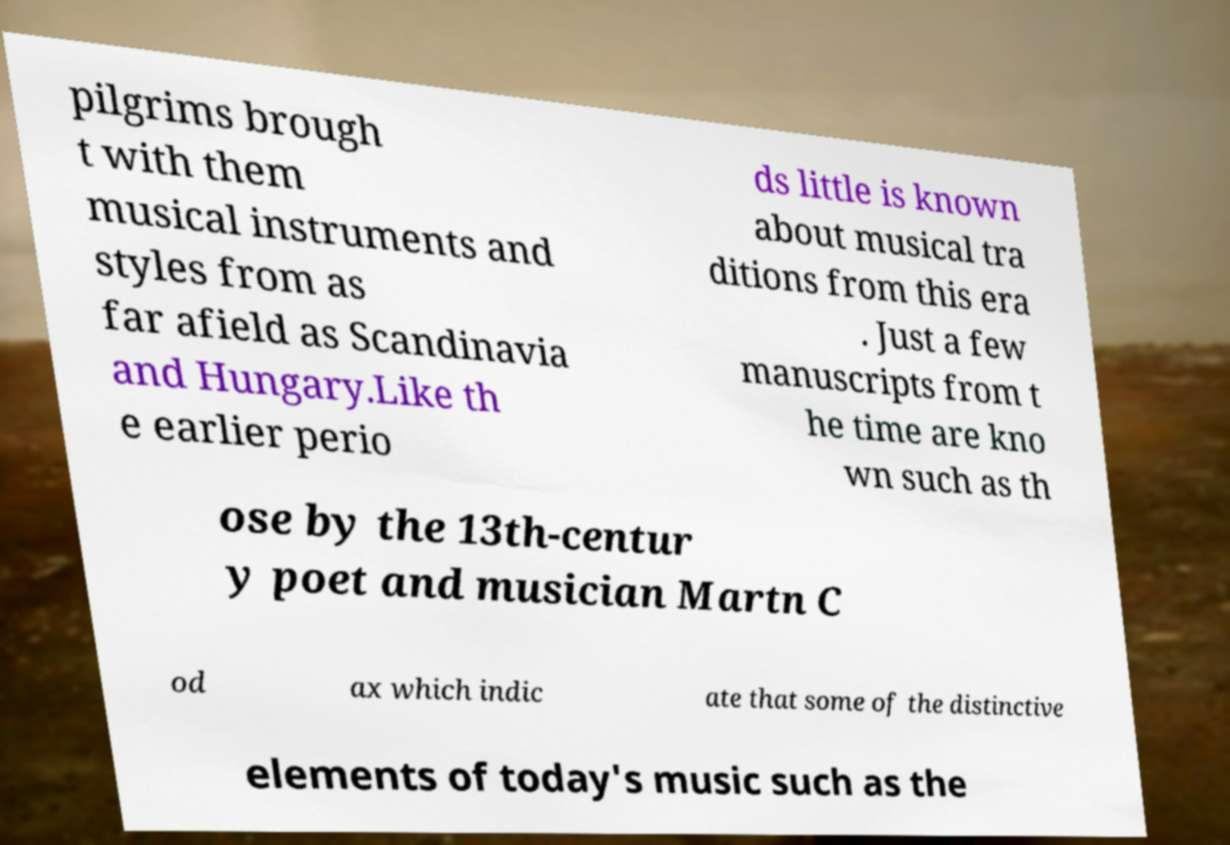Can you read and provide the text displayed in the image?This photo seems to have some interesting text. Can you extract and type it out for me? pilgrims brough t with them musical instruments and styles from as far afield as Scandinavia and Hungary.Like th e earlier perio ds little is known about musical tra ditions from this era . Just a few manuscripts from t he time are kno wn such as th ose by the 13th-centur y poet and musician Martn C od ax which indic ate that some of the distinctive elements of today's music such as the 